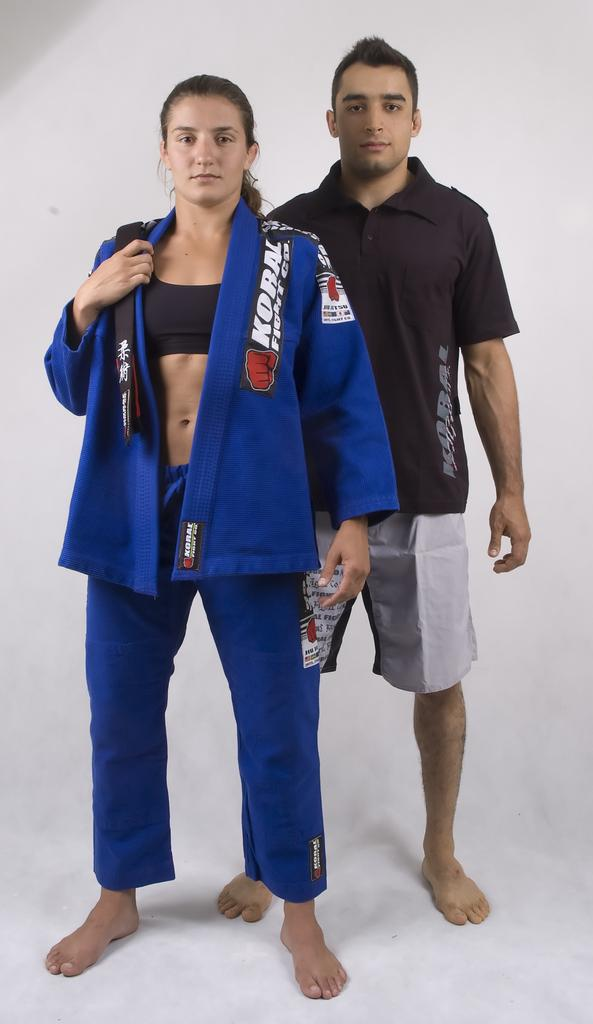Who are the people in the image? There is a woman and a man in the image. What are the positions of the man and woman in the image? The man and woman are standing in the middle of the image. What is the color of the background in the image? The background of the image is white. What type of haircut does the zinc have in the image? There is no zinc present in the image, and therefore no haircut can be observed. 